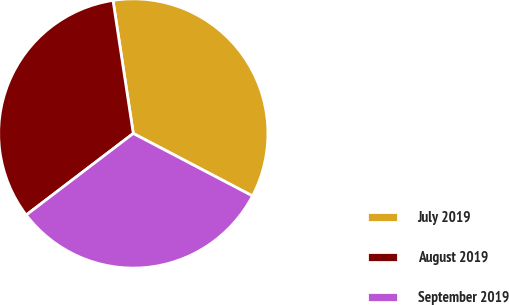<chart> <loc_0><loc_0><loc_500><loc_500><pie_chart><fcel>July 2019<fcel>August 2019<fcel>September 2019<nl><fcel>35.09%<fcel>32.95%<fcel>31.96%<nl></chart> 